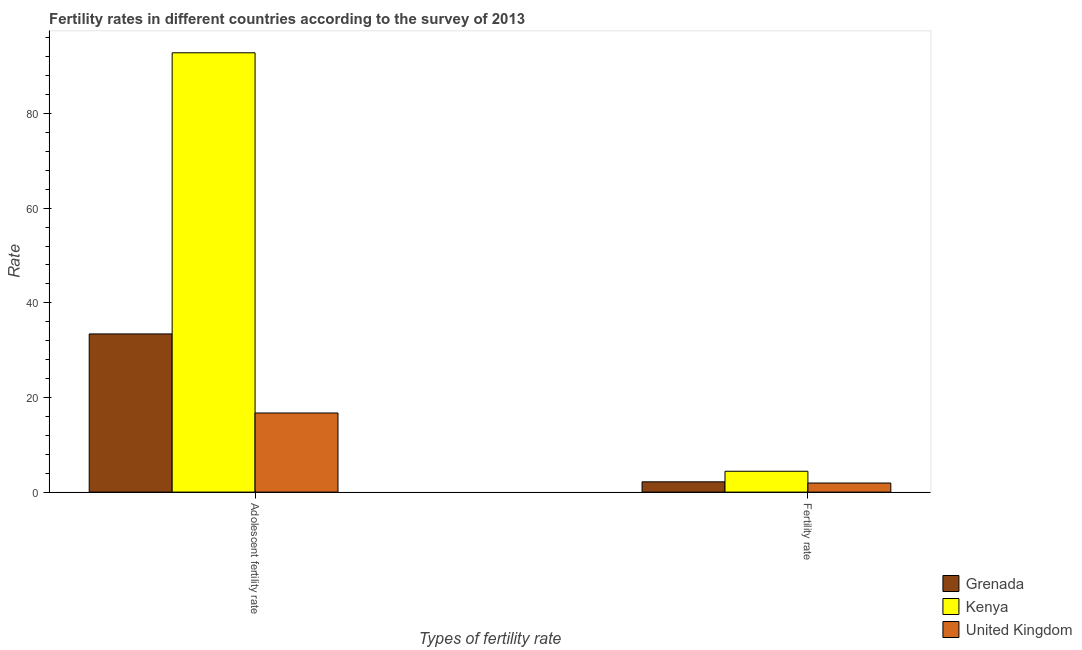How many groups of bars are there?
Your answer should be very brief. 2. Are the number of bars per tick equal to the number of legend labels?
Your answer should be compact. Yes. Are the number of bars on each tick of the X-axis equal?
Your answer should be very brief. Yes. How many bars are there on the 2nd tick from the right?
Provide a succinct answer. 3. What is the label of the 1st group of bars from the left?
Your answer should be compact. Adolescent fertility rate. What is the fertility rate in United Kingdom?
Keep it short and to the point. 1.92. Across all countries, what is the maximum fertility rate?
Offer a very short reply. 4.41. Across all countries, what is the minimum fertility rate?
Your answer should be very brief. 1.92. In which country was the adolescent fertility rate maximum?
Provide a short and direct response. Kenya. What is the total fertility rate in the graph?
Offer a terse response. 8.5. What is the difference between the adolescent fertility rate in Kenya and that in Grenada?
Keep it short and to the point. 59.42. What is the difference between the fertility rate in Grenada and the adolescent fertility rate in United Kingdom?
Keep it short and to the point. -14.55. What is the average fertility rate per country?
Your answer should be very brief. 2.83. What is the difference between the fertility rate and adolescent fertility rate in Grenada?
Your response must be concise. -31.26. In how many countries, is the fertility rate greater than 4 ?
Offer a very short reply. 1. What is the ratio of the adolescent fertility rate in Kenya to that in United Kingdom?
Your answer should be very brief. 5.55. Is the fertility rate in Kenya less than that in United Kingdom?
Give a very brief answer. No. What does the 3rd bar from the left in Fertility rate represents?
Provide a short and direct response. United Kingdom. What does the 3rd bar from the right in Adolescent fertility rate represents?
Ensure brevity in your answer.  Grenada. How many bars are there?
Your answer should be compact. 6. How many countries are there in the graph?
Offer a very short reply. 3. How are the legend labels stacked?
Your answer should be very brief. Vertical. What is the title of the graph?
Offer a very short reply. Fertility rates in different countries according to the survey of 2013. What is the label or title of the X-axis?
Ensure brevity in your answer.  Types of fertility rate. What is the label or title of the Y-axis?
Offer a very short reply. Rate. What is the Rate of Grenada in Adolescent fertility rate?
Your response must be concise. 33.43. What is the Rate in Kenya in Adolescent fertility rate?
Give a very brief answer. 92.84. What is the Rate in United Kingdom in Adolescent fertility rate?
Keep it short and to the point. 16.72. What is the Rate of Grenada in Fertility rate?
Your answer should be compact. 2.17. What is the Rate of Kenya in Fertility rate?
Your answer should be compact. 4.41. What is the Rate in United Kingdom in Fertility rate?
Provide a short and direct response. 1.92. Across all Types of fertility rate, what is the maximum Rate of Grenada?
Provide a succinct answer. 33.43. Across all Types of fertility rate, what is the maximum Rate of Kenya?
Offer a terse response. 92.84. Across all Types of fertility rate, what is the maximum Rate in United Kingdom?
Give a very brief answer. 16.72. Across all Types of fertility rate, what is the minimum Rate in Grenada?
Your answer should be very brief. 2.17. Across all Types of fertility rate, what is the minimum Rate in Kenya?
Offer a very short reply. 4.41. Across all Types of fertility rate, what is the minimum Rate of United Kingdom?
Ensure brevity in your answer.  1.92. What is the total Rate in Grenada in the graph?
Provide a short and direct response. 35.6. What is the total Rate of Kenya in the graph?
Ensure brevity in your answer.  97.25. What is the total Rate in United Kingdom in the graph?
Provide a short and direct response. 18.64. What is the difference between the Rate of Grenada in Adolescent fertility rate and that in Fertility rate?
Ensure brevity in your answer.  31.26. What is the difference between the Rate of Kenya in Adolescent fertility rate and that in Fertility rate?
Keep it short and to the point. 88.44. What is the difference between the Rate in United Kingdom in Adolescent fertility rate and that in Fertility rate?
Your answer should be very brief. 14.8. What is the difference between the Rate of Grenada in Adolescent fertility rate and the Rate of Kenya in Fertility rate?
Give a very brief answer. 29.02. What is the difference between the Rate of Grenada in Adolescent fertility rate and the Rate of United Kingdom in Fertility rate?
Make the answer very short. 31.51. What is the difference between the Rate in Kenya in Adolescent fertility rate and the Rate in United Kingdom in Fertility rate?
Offer a terse response. 90.92. What is the average Rate in Grenada per Types of fertility rate?
Your answer should be compact. 17.8. What is the average Rate of Kenya per Types of fertility rate?
Provide a succinct answer. 48.62. What is the average Rate of United Kingdom per Types of fertility rate?
Keep it short and to the point. 9.32. What is the difference between the Rate in Grenada and Rate in Kenya in Adolescent fertility rate?
Offer a terse response. -59.42. What is the difference between the Rate in Grenada and Rate in United Kingdom in Adolescent fertility rate?
Offer a very short reply. 16.71. What is the difference between the Rate of Kenya and Rate of United Kingdom in Adolescent fertility rate?
Offer a terse response. 76.12. What is the difference between the Rate in Grenada and Rate in Kenya in Fertility rate?
Your answer should be very brief. -2.23. What is the difference between the Rate in Grenada and Rate in United Kingdom in Fertility rate?
Ensure brevity in your answer.  0.25. What is the difference between the Rate of Kenya and Rate of United Kingdom in Fertility rate?
Offer a very short reply. 2.49. What is the ratio of the Rate of Grenada in Adolescent fertility rate to that in Fertility rate?
Your response must be concise. 15.4. What is the ratio of the Rate in Kenya in Adolescent fertility rate to that in Fertility rate?
Keep it short and to the point. 21.07. What is the ratio of the Rate in United Kingdom in Adolescent fertility rate to that in Fertility rate?
Your answer should be compact. 8.71. What is the difference between the highest and the second highest Rate in Grenada?
Your answer should be very brief. 31.26. What is the difference between the highest and the second highest Rate of Kenya?
Your answer should be compact. 88.44. What is the difference between the highest and the second highest Rate in United Kingdom?
Provide a succinct answer. 14.8. What is the difference between the highest and the lowest Rate in Grenada?
Your answer should be very brief. 31.26. What is the difference between the highest and the lowest Rate in Kenya?
Offer a terse response. 88.44. What is the difference between the highest and the lowest Rate in United Kingdom?
Your response must be concise. 14.8. 